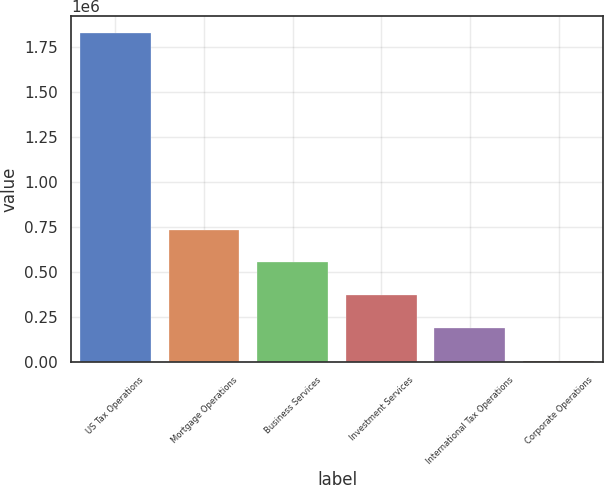Convert chart. <chart><loc_0><loc_0><loc_500><loc_500><bar_chart><fcel>US Tax Operations<fcel>Mortgage Operations<fcel>Business Services<fcel>Investment Services<fcel>International Tax Operations<fcel>Corporate Operations<nl><fcel>1.83127e+06<fcel>735973<fcel>553423<fcel>370873<fcel>188323<fcel>5773<nl></chart> 